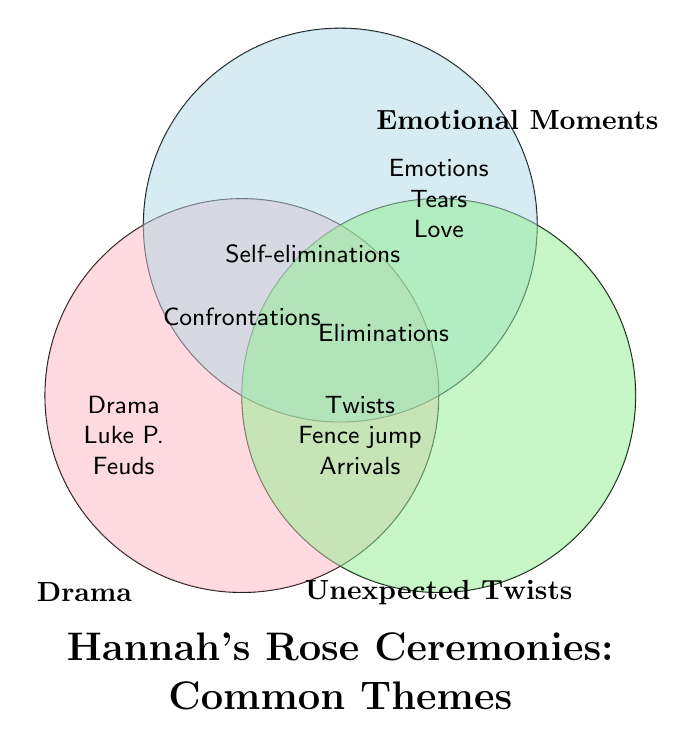Which theme appears in all three categories? "Confrontations" is situated at the center where all three sets overlap, indicating it belongs to Drama, Emotional Moments, and Unexpected Twists.
Answer: Confrontations What distinct theme is associated with "Drama" only? "Drama" has themes listed exclusively within its circle without overlap: "Luke P. controversy" and "Contestant feuds."
Answer: Luke P. controversy and Contestant feuds How many themes are shared between "Emotional Moments" and "Unexpected Twists"? By observing the overlap of Emotional Moments and Unexpected Twists (excluding Drama), we find two themes: "Declarations of love" and "Surprise eliminations."
Answer: 2 Which unique theme is located inside the "Emotional Moments" circle but not shared with any other themes? "Heartfelt conversations" is found exclusively within the Emotional Moments circle.
Answer: Heartfelt conversations List the themes that are common between "Drama" and "Unexpected Twists." Overlapping themes between Drama and Unexpected Twists are "Eliminations" and "Self-eliminations."
Answer: Eliminations and Self-eliminations Which themes are not shared with any other categories in "Unexpected Twists"? The themes exclusive to Unexpected Twists are "Fence jump" and "Last-minute arrivals."
Answer: Fence jump and Last-minute arrivals What common theme is present in both "Emotional Moments" and "Drama" but not in "Unexpected Twists"? The theme shared only between Emotional Moments and Drama is "Tears."
Answer: Tears 